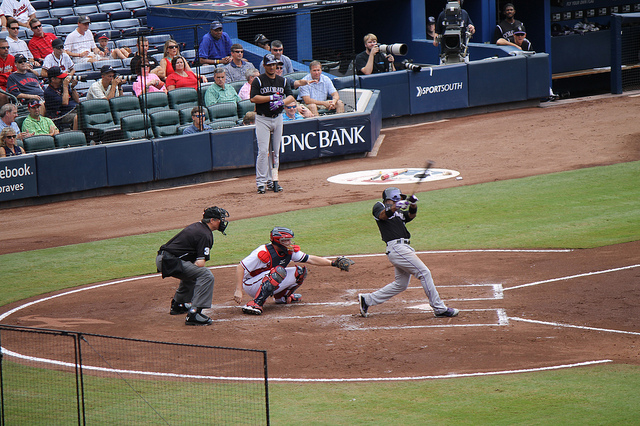Identify the text displayed in this image. PNCBANK SPORTSOUTH 3 ebook. raves 